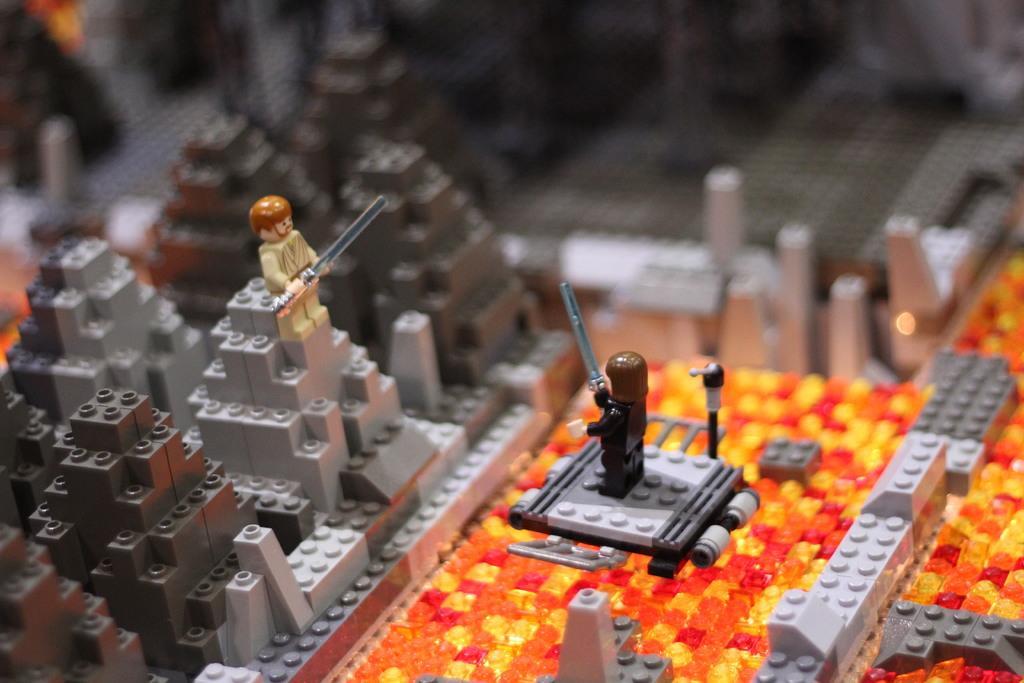How would you summarize this image in a sentence or two? In this image we can see legos. 